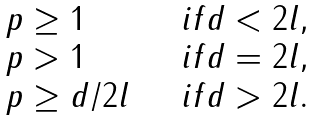<formula> <loc_0><loc_0><loc_500><loc_500>\begin{array} { l l } p \geq 1 \quad & i f d < 2 l , \\ p > 1 \quad & i f d = 2 l , \\ p \geq d / 2 l \quad & i f d > 2 l . \end{array}</formula> 